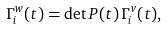<formula> <loc_0><loc_0><loc_500><loc_500>\Gamma _ { i } ^ { w } ( t ) = \det P ( t ) \, \Gamma _ { i } ^ { v } ( t ) ,</formula> 